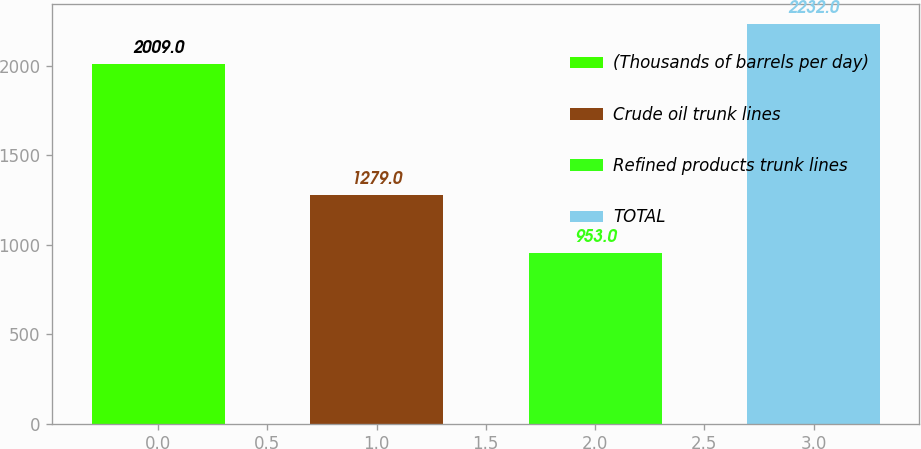<chart> <loc_0><loc_0><loc_500><loc_500><bar_chart><fcel>(Thousands of barrels per day)<fcel>Crude oil trunk lines<fcel>Refined products trunk lines<fcel>TOTAL<nl><fcel>2009<fcel>1279<fcel>953<fcel>2232<nl></chart> 